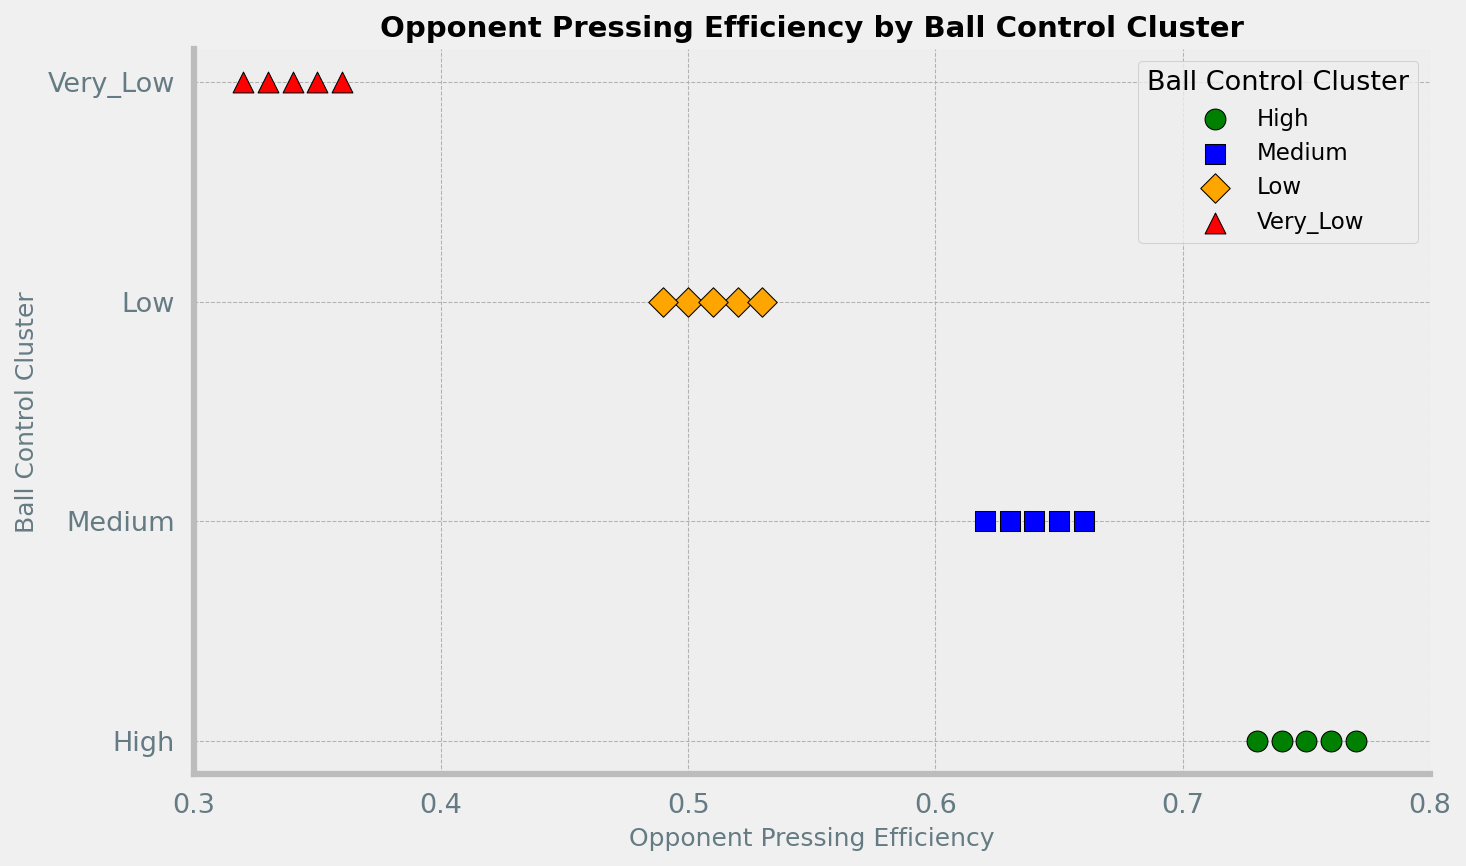What color represents the 'Low' Ball Control Cluster? The 'Low' Ball Control Cluster is indicated by the color orange, which can be observed from the markers in the plot.
Answer: Orange Which Ball Control Cluster has the least opponent pressing efficiency? The cluster with the least opponent pressing efficiency is 'Very_Low', as it has data points around the 0.32-0.36 range on the x-axis.
Answer: Very_Low What is the average opponent pressing efficiency for the 'Medium' Ball Control Cluster? The opponent pressing efficiencies for the 'Medium' cluster are 0.65, 0.64, 0.66, 0.63, and 0.62. Adding these, (0.65 + 0.64 + 0.66 + 0.63 + 0.62) = 3.20, and the average is 3.20 / 5 = 0.64.
Answer: 0.64 Compare the highest value of opponent pressing efficiency in the 'Low' and 'Very_Low' clusters. Which is higher? The highest value in the 'Low' cluster is 0.53, and the highest in the 'Very_Low' cluster is 0.36. Therefore, the 'Low' cluster has a higher pressing efficiency.
Answer: Low How many Ball Control Clusters have an opponent pressing efficiency below 0.55? Both the 'Low' and 'Very_Low' Ball Control Clusters have pressing efficiencies below 0.55. 'Low' ranges between 0.49-0.53, and 'Very_Low' ranges between 0.32-0.36.
Answer: 2 What can you infer about the relationship between Ball Control Clusters and opponent pressing efficiency? As the Ball Control Cluster moves from 'High' to 'Very_Low', the opponent pressing efficiency values decrease. This signifies that teams with better ball control face higher pressing efficiency from opponents.
Answer: Decreases with lower ball control Which Ball Control Cluster has the smallest spread in opponent pressing efficiency values? The 'Very_Low' Ball Control Cluster has the smallest spread, with values ranging from 0.32 to 0.36, indicating the lowest variability among all clusters.
Answer: Very_Low What is the difference in the highest opponent pressing efficiency values between the 'High' and 'Low' clusters? The highest value for the 'High' cluster is 0.77, and for the 'Low' cluster, it is 0.53. The difference is 0.77 - 0.53 = 0.24.
Answer: 0.24 Which Ball Control Cluster has the markers with a black edge? All the clusters have markers with a black edge, as seen by the edge color around their respective markers in the plot.
Answer: All clusters 